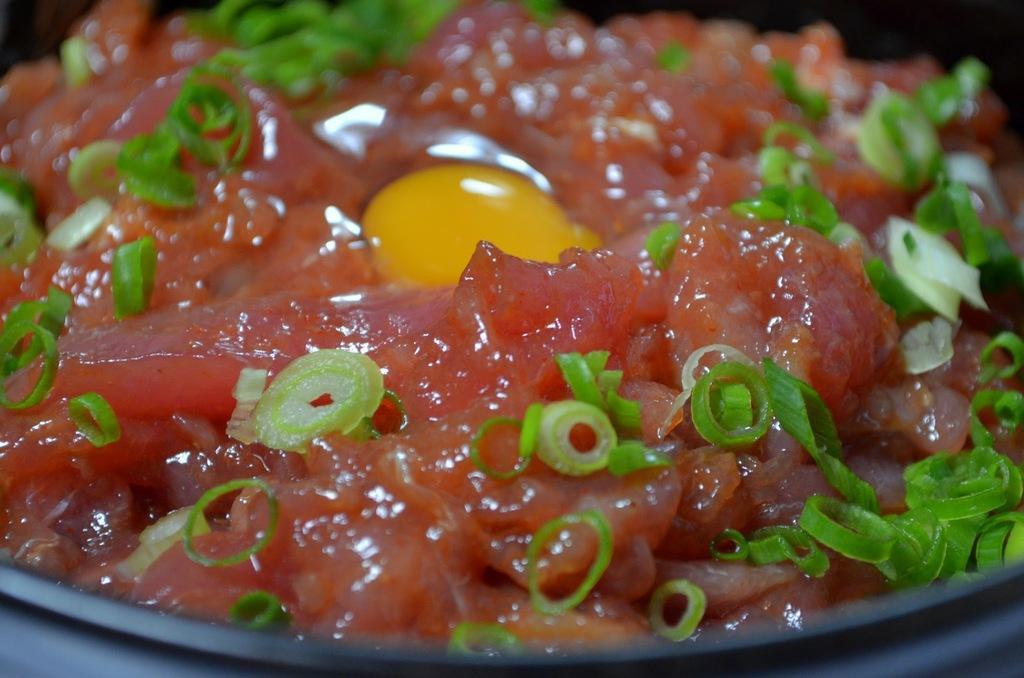Could you give a brief overview of what you see in this image? This is the picture of a food item on which there are some green chilies garnished. 